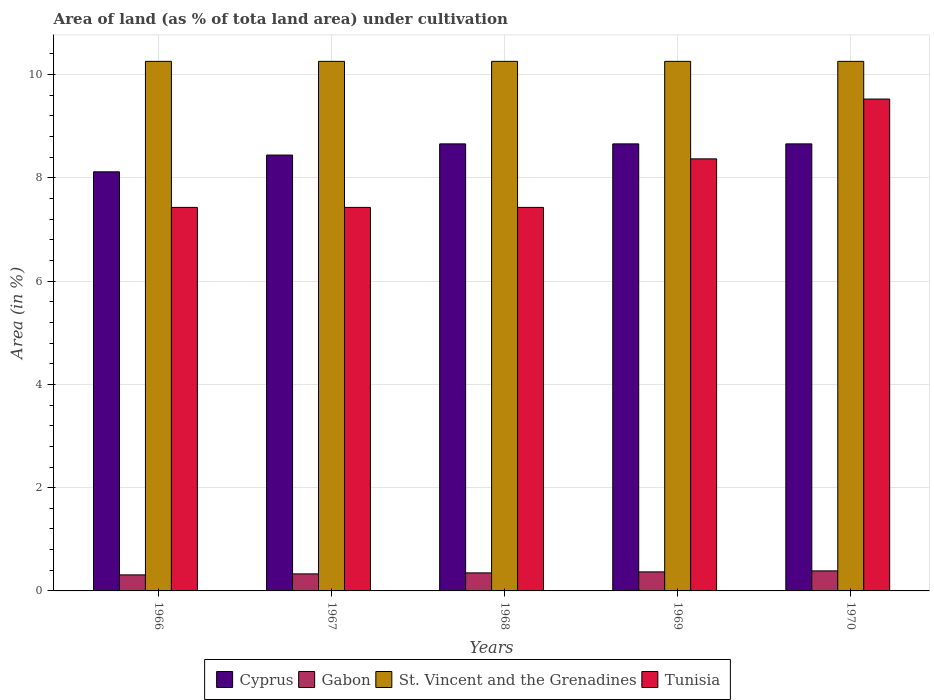How many different coloured bars are there?
Your answer should be very brief. 4. How many groups of bars are there?
Provide a short and direct response. 5. Are the number of bars per tick equal to the number of legend labels?
Provide a short and direct response. Yes. What is the label of the 2nd group of bars from the left?
Keep it short and to the point. 1967. In how many cases, is the number of bars for a given year not equal to the number of legend labels?
Keep it short and to the point. 0. What is the percentage of land under cultivation in St. Vincent and the Grenadines in 1968?
Ensure brevity in your answer.  10.26. Across all years, what is the maximum percentage of land under cultivation in Cyprus?
Your response must be concise. 8.66. Across all years, what is the minimum percentage of land under cultivation in Cyprus?
Keep it short and to the point. 8.12. In which year was the percentage of land under cultivation in Cyprus minimum?
Ensure brevity in your answer.  1966. What is the total percentage of land under cultivation in Tunisia in the graph?
Ensure brevity in your answer.  40.18. What is the difference between the percentage of land under cultivation in Gabon in 1966 and that in 1967?
Offer a terse response. -0.02. What is the difference between the percentage of land under cultivation in Cyprus in 1969 and the percentage of land under cultivation in St. Vincent and the Grenadines in 1966?
Provide a short and direct response. -1.6. What is the average percentage of land under cultivation in Gabon per year?
Make the answer very short. 0.35. In the year 1970, what is the difference between the percentage of land under cultivation in Cyprus and percentage of land under cultivation in St. Vincent and the Grenadines?
Give a very brief answer. -1.6. Is the percentage of land under cultivation in St. Vincent and the Grenadines in 1966 less than that in 1970?
Your answer should be very brief. No. Is the difference between the percentage of land under cultivation in Cyprus in 1966 and 1969 greater than the difference between the percentage of land under cultivation in St. Vincent and the Grenadines in 1966 and 1969?
Offer a terse response. No. What is the difference between the highest and the lowest percentage of land under cultivation in St. Vincent and the Grenadines?
Give a very brief answer. 0. Is the sum of the percentage of land under cultivation in Gabon in 1966 and 1967 greater than the maximum percentage of land under cultivation in Cyprus across all years?
Ensure brevity in your answer.  No. What does the 3rd bar from the left in 1966 represents?
Provide a short and direct response. St. Vincent and the Grenadines. What does the 2nd bar from the right in 1969 represents?
Provide a succinct answer. St. Vincent and the Grenadines. How many bars are there?
Provide a short and direct response. 20. How many years are there in the graph?
Provide a succinct answer. 5. What is the difference between two consecutive major ticks on the Y-axis?
Give a very brief answer. 2. Are the values on the major ticks of Y-axis written in scientific E-notation?
Give a very brief answer. No. Where does the legend appear in the graph?
Make the answer very short. Bottom center. What is the title of the graph?
Offer a very short reply. Area of land (as % of tota land area) under cultivation. Does "Korea (Republic)" appear as one of the legend labels in the graph?
Keep it short and to the point. No. What is the label or title of the X-axis?
Offer a very short reply. Years. What is the label or title of the Y-axis?
Provide a short and direct response. Area (in %). What is the Area (in %) of Cyprus in 1966?
Your response must be concise. 8.12. What is the Area (in %) in Gabon in 1966?
Your response must be concise. 0.31. What is the Area (in %) in St. Vincent and the Grenadines in 1966?
Your response must be concise. 10.26. What is the Area (in %) in Tunisia in 1966?
Provide a succinct answer. 7.43. What is the Area (in %) of Cyprus in 1967?
Offer a very short reply. 8.44. What is the Area (in %) in Gabon in 1967?
Offer a very short reply. 0.33. What is the Area (in %) in St. Vincent and the Grenadines in 1967?
Your answer should be compact. 10.26. What is the Area (in %) in Tunisia in 1967?
Offer a terse response. 7.43. What is the Area (in %) in Cyprus in 1968?
Your answer should be compact. 8.66. What is the Area (in %) in Gabon in 1968?
Provide a short and direct response. 0.35. What is the Area (in %) of St. Vincent and the Grenadines in 1968?
Provide a short and direct response. 10.26. What is the Area (in %) in Tunisia in 1968?
Your answer should be compact. 7.43. What is the Area (in %) of Cyprus in 1969?
Ensure brevity in your answer.  8.66. What is the Area (in %) of Gabon in 1969?
Offer a terse response. 0.37. What is the Area (in %) in St. Vincent and the Grenadines in 1969?
Ensure brevity in your answer.  10.26. What is the Area (in %) of Tunisia in 1969?
Ensure brevity in your answer.  8.37. What is the Area (in %) in Cyprus in 1970?
Ensure brevity in your answer.  8.66. What is the Area (in %) of Gabon in 1970?
Provide a succinct answer. 0.39. What is the Area (in %) of St. Vincent and the Grenadines in 1970?
Ensure brevity in your answer.  10.26. What is the Area (in %) of Tunisia in 1970?
Offer a very short reply. 9.53. Across all years, what is the maximum Area (in %) in Cyprus?
Your answer should be very brief. 8.66. Across all years, what is the maximum Area (in %) of Gabon?
Your answer should be very brief. 0.39. Across all years, what is the maximum Area (in %) of St. Vincent and the Grenadines?
Your answer should be very brief. 10.26. Across all years, what is the maximum Area (in %) of Tunisia?
Keep it short and to the point. 9.53. Across all years, what is the minimum Area (in %) of Cyprus?
Your answer should be compact. 8.12. Across all years, what is the minimum Area (in %) of Gabon?
Provide a succinct answer. 0.31. Across all years, what is the minimum Area (in %) in St. Vincent and the Grenadines?
Offer a very short reply. 10.26. Across all years, what is the minimum Area (in %) in Tunisia?
Keep it short and to the point. 7.43. What is the total Area (in %) of Cyprus in the graph?
Make the answer very short. 42.53. What is the total Area (in %) of Gabon in the graph?
Offer a terse response. 1.75. What is the total Area (in %) in St. Vincent and the Grenadines in the graph?
Offer a very short reply. 51.28. What is the total Area (in %) in Tunisia in the graph?
Your response must be concise. 40.18. What is the difference between the Area (in %) in Cyprus in 1966 and that in 1967?
Your answer should be compact. -0.32. What is the difference between the Area (in %) of Gabon in 1966 and that in 1967?
Offer a terse response. -0.02. What is the difference between the Area (in %) of St. Vincent and the Grenadines in 1966 and that in 1967?
Your answer should be compact. 0. What is the difference between the Area (in %) in Cyprus in 1966 and that in 1968?
Keep it short and to the point. -0.54. What is the difference between the Area (in %) of Gabon in 1966 and that in 1968?
Your response must be concise. -0.04. What is the difference between the Area (in %) in St. Vincent and the Grenadines in 1966 and that in 1968?
Provide a short and direct response. 0. What is the difference between the Area (in %) in Cyprus in 1966 and that in 1969?
Offer a terse response. -0.54. What is the difference between the Area (in %) of Gabon in 1966 and that in 1969?
Make the answer very short. -0.06. What is the difference between the Area (in %) of St. Vincent and the Grenadines in 1966 and that in 1969?
Ensure brevity in your answer.  0. What is the difference between the Area (in %) of Tunisia in 1966 and that in 1969?
Make the answer very short. -0.94. What is the difference between the Area (in %) in Cyprus in 1966 and that in 1970?
Give a very brief answer. -0.54. What is the difference between the Area (in %) of Gabon in 1966 and that in 1970?
Provide a short and direct response. -0.08. What is the difference between the Area (in %) in Tunisia in 1966 and that in 1970?
Ensure brevity in your answer.  -2.1. What is the difference between the Area (in %) in Cyprus in 1967 and that in 1968?
Make the answer very short. -0.22. What is the difference between the Area (in %) of Gabon in 1967 and that in 1968?
Make the answer very short. -0.02. What is the difference between the Area (in %) of Tunisia in 1967 and that in 1968?
Offer a very short reply. 0. What is the difference between the Area (in %) of Cyprus in 1967 and that in 1969?
Provide a succinct answer. -0.22. What is the difference between the Area (in %) of Gabon in 1967 and that in 1969?
Ensure brevity in your answer.  -0.04. What is the difference between the Area (in %) in St. Vincent and the Grenadines in 1967 and that in 1969?
Ensure brevity in your answer.  0. What is the difference between the Area (in %) of Tunisia in 1967 and that in 1969?
Offer a very short reply. -0.94. What is the difference between the Area (in %) of Cyprus in 1967 and that in 1970?
Your answer should be compact. -0.22. What is the difference between the Area (in %) of Gabon in 1967 and that in 1970?
Your answer should be very brief. -0.06. What is the difference between the Area (in %) in St. Vincent and the Grenadines in 1967 and that in 1970?
Ensure brevity in your answer.  0. What is the difference between the Area (in %) in Tunisia in 1967 and that in 1970?
Provide a short and direct response. -2.1. What is the difference between the Area (in %) of Gabon in 1968 and that in 1969?
Keep it short and to the point. -0.02. What is the difference between the Area (in %) of Tunisia in 1968 and that in 1969?
Give a very brief answer. -0.94. What is the difference between the Area (in %) in Gabon in 1968 and that in 1970?
Offer a terse response. -0.04. What is the difference between the Area (in %) in St. Vincent and the Grenadines in 1968 and that in 1970?
Provide a short and direct response. 0. What is the difference between the Area (in %) in Tunisia in 1968 and that in 1970?
Your answer should be compact. -2.1. What is the difference between the Area (in %) of Cyprus in 1969 and that in 1970?
Give a very brief answer. 0. What is the difference between the Area (in %) of Gabon in 1969 and that in 1970?
Make the answer very short. -0.02. What is the difference between the Area (in %) in Tunisia in 1969 and that in 1970?
Your answer should be very brief. -1.16. What is the difference between the Area (in %) in Cyprus in 1966 and the Area (in %) in Gabon in 1967?
Provide a succinct answer. 7.79. What is the difference between the Area (in %) in Cyprus in 1966 and the Area (in %) in St. Vincent and the Grenadines in 1967?
Ensure brevity in your answer.  -2.14. What is the difference between the Area (in %) of Cyprus in 1966 and the Area (in %) of Tunisia in 1967?
Your answer should be very brief. 0.69. What is the difference between the Area (in %) of Gabon in 1966 and the Area (in %) of St. Vincent and the Grenadines in 1967?
Ensure brevity in your answer.  -9.95. What is the difference between the Area (in %) in Gabon in 1966 and the Area (in %) in Tunisia in 1967?
Provide a succinct answer. -7.12. What is the difference between the Area (in %) in St. Vincent and the Grenadines in 1966 and the Area (in %) in Tunisia in 1967?
Your response must be concise. 2.83. What is the difference between the Area (in %) of Cyprus in 1966 and the Area (in %) of Gabon in 1968?
Provide a succinct answer. 7.77. What is the difference between the Area (in %) in Cyprus in 1966 and the Area (in %) in St. Vincent and the Grenadines in 1968?
Provide a succinct answer. -2.14. What is the difference between the Area (in %) in Cyprus in 1966 and the Area (in %) in Tunisia in 1968?
Give a very brief answer. 0.69. What is the difference between the Area (in %) in Gabon in 1966 and the Area (in %) in St. Vincent and the Grenadines in 1968?
Your answer should be compact. -9.95. What is the difference between the Area (in %) of Gabon in 1966 and the Area (in %) of Tunisia in 1968?
Ensure brevity in your answer.  -7.12. What is the difference between the Area (in %) in St. Vincent and the Grenadines in 1966 and the Area (in %) in Tunisia in 1968?
Make the answer very short. 2.83. What is the difference between the Area (in %) of Cyprus in 1966 and the Area (in %) of Gabon in 1969?
Provide a succinct answer. 7.75. What is the difference between the Area (in %) of Cyprus in 1966 and the Area (in %) of St. Vincent and the Grenadines in 1969?
Make the answer very short. -2.14. What is the difference between the Area (in %) in Cyprus in 1966 and the Area (in %) in Tunisia in 1969?
Ensure brevity in your answer.  -0.25. What is the difference between the Area (in %) of Gabon in 1966 and the Area (in %) of St. Vincent and the Grenadines in 1969?
Provide a succinct answer. -9.95. What is the difference between the Area (in %) of Gabon in 1966 and the Area (in %) of Tunisia in 1969?
Keep it short and to the point. -8.06. What is the difference between the Area (in %) in St. Vincent and the Grenadines in 1966 and the Area (in %) in Tunisia in 1969?
Offer a very short reply. 1.89. What is the difference between the Area (in %) of Cyprus in 1966 and the Area (in %) of Gabon in 1970?
Your answer should be compact. 7.73. What is the difference between the Area (in %) in Cyprus in 1966 and the Area (in %) in St. Vincent and the Grenadines in 1970?
Give a very brief answer. -2.14. What is the difference between the Area (in %) in Cyprus in 1966 and the Area (in %) in Tunisia in 1970?
Make the answer very short. -1.41. What is the difference between the Area (in %) of Gabon in 1966 and the Area (in %) of St. Vincent and the Grenadines in 1970?
Keep it short and to the point. -9.95. What is the difference between the Area (in %) in Gabon in 1966 and the Area (in %) in Tunisia in 1970?
Provide a succinct answer. -9.22. What is the difference between the Area (in %) in St. Vincent and the Grenadines in 1966 and the Area (in %) in Tunisia in 1970?
Make the answer very short. 0.73. What is the difference between the Area (in %) in Cyprus in 1967 and the Area (in %) in Gabon in 1968?
Your response must be concise. 8.09. What is the difference between the Area (in %) of Cyprus in 1967 and the Area (in %) of St. Vincent and the Grenadines in 1968?
Provide a succinct answer. -1.81. What is the difference between the Area (in %) in Cyprus in 1967 and the Area (in %) in Tunisia in 1968?
Your answer should be very brief. 1.01. What is the difference between the Area (in %) of Gabon in 1967 and the Area (in %) of St. Vincent and the Grenadines in 1968?
Make the answer very short. -9.93. What is the difference between the Area (in %) of Gabon in 1967 and the Area (in %) of Tunisia in 1968?
Offer a terse response. -7.1. What is the difference between the Area (in %) of St. Vincent and the Grenadines in 1967 and the Area (in %) of Tunisia in 1968?
Your answer should be very brief. 2.83. What is the difference between the Area (in %) of Cyprus in 1967 and the Area (in %) of Gabon in 1969?
Provide a succinct answer. 8.07. What is the difference between the Area (in %) of Cyprus in 1967 and the Area (in %) of St. Vincent and the Grenadines in 1969?
Your answer should be compact. -1.81. What is the difference between the Area (in %) in Cyprus in 1967 and the Area (in %) in Tunisia in 1969?
Provide a succinct answer. 0.07. What is the difference between the Area (in %) of Gabon in 1967 and the Area (in %) of St. Vincent and the Grenadines in 1969?
Provide a succinct answer. -9.93. What is the difference between the Area (in %) of Gabon in 1967 and the Area (in %) of Tunisia in 1969?
Your answer should be compact. -8.04. What is the difference between the Area (in %) of St. Vincent and the Grenadines in 1967 and the Area (in %) of Tunisia in 1969?
Your response must be concise. 1.89. What is the difference between the Area (in %) of Cyprus in 1967 and the Area (in %) of Gabon in 1970?
Make the answer very short. 8.05. What is the difference between the Area (in %) of Cyprus in 1967 and the Area (in %) of St. Vincent and the Grenadines in 1970?
Your answer should be compact. -1.81. What is the difference between the Area (in %) of Cyprus in 1967 and the Area (in %) of Tunisia in 1970?
Provide a short and direct response. -1.08. What is the difference between the Area (in %) in Gabon in 1967 and the Area (in %) in St. Vincent and the Grenadines in 1970?
Give a very brief answer. -9.93. What is the difference between the Area (in %) of Gabon in 1967 and the Area (in %) of Tunisia in 1970?
Your answer should be very brief. -9.2. What is the difference between the Area (in %) of St. Vincent and the Grenadines in 1967 and the Area (in %) of Tunisia in 1970?
Keep it short and to the point. 0.73. What is the difference between the Area (in %) of Cyprus in 1968 and the Area (in %) of Gabon in 1969?
Your answer should be compact. 8.29. What is the difference between the Area (in %) of Cyprus in 1968 and the Area (in %) of St. Vincent and the Grenadines in 1969?
Your response must be concise. -1.6. What is the difference between the Area (in %) of Cyprus in 1968 and the Area (in %) of Tunisia in 1969?
Your answer should be compact. 0.29. What is the difference between the Area (in %) in Gabon in 1968 and the Area (in %) in St. Vincent and the Grenadines in 1969?
Offer a very short reply. -9.91. What is the difference between the Area (in %) of Gabon in 1968 and the Area (in %) of Tunisia in 1969?
Your answer should be compact. -8.02. What is the difference between the Area (in %) in St. Vincent and the Grenadines in 1968 and the Area (in %) in Tunisia in 1969?
Provide a succinct answer. 1.89. What is the difference between the Area (in %) of Cyprus in 1968 and the Area (in %) of Gabon in 1970?
Make the answer very short. 8.27. What is the difference between the Area (in %) of Cyprus in 1968 and the Area (in %) of St. Vincent and the Grenadines in 1970?
Your answer should be compact. -1.6. What is the difference between the Area (in %) in Cyprus in 1968 and the Area (in %) in Tunisia in 1970?
Make the answer very short. -0.87. What is the difference between the Area (in %) in Gabon in 1968 and the Area (in %) in St. Vincent and the Grenadines in 1970?
Your answer should be very brief. -9.91. What is the difference between the Area (in %) in Gabon in 1968 and the Area (in %) in Tunisia in 1970?
Ensure brevity in your answer.  -9.18. What is the difference between the Area (in %) in St. Vincent and the Grenadines in 1968 and the Area (in %) in Tunisia in 1970?
Your answer should be very brief. 0.73. What is the difference between the Area (in %) of Cyprus in 1969 and the Area (in %) of Gabon in 1970?
Provide a succinct answer. 8.27. What is the difference between the Area (in %) in Cyprus in 1969 and the Area (in %) in St. Vincent and the Grenadines in 1970?
Your answer should be compact. -1.6. What is the difference between the Area (in %) in Cyprus in 1969 and the Area (in %) in Tunisia in 1970?
Make the answer very short. -0.87. What is the difference between the Area (in %) in Gabon in 1969 and the Area (in %) in St. Vincent and the Grenadines in 1970?
Give a very brief answer. -9.89. What is the difference between the Area (in %) in Gabon in 1969 and the Area (in %) in Tunisia in 1970?
Offer a terse response. -9.16. What is the difference between the Area (in %) in St. Vincent and the Grenadines in 1969 and the Area (in %) in Tunisia in 1970?
Your answer should be compact. 0.73. What is the average Area (in %) in Cyprus per year?
Your answer should be very brief. 8.51. What is the average Area (in %) of Gabon per year?
Offer a very short reply. 0.35. What is the average Area (in %) of St. Vincent and the Grenadines per year?
Your response must be concise. 10.26. What is the average Area (in %) in Tunisia per year?
Provide a succinct answer. 8.04. In the year 1966, what is the difference between the Area (in %) of Cyprus and Area (in %) of Gabon?
Provide a succinct answer. 7.81. In the year 1966, what is the difference between the Area (in %) of Cyprus and Area (in %) of St. Vincent and the Grenadines?
Offer a terse response. -2.14. In the year 1966, what is the difference between the Area (in %) in Cyprus and Area (in %) in Tunisia?
Your response must be concise. 0.69. In the year 1966, what is the difference between the Area (in %) of Gabon and Area (in %) of St. Vincent and the Grenadines?
Your answer should be very brief. -9.95. In the year 1966, what is the difference between the Area (in %) in Gabon and Area (in %) in Tunisia?
Keep it short and to the point. -7.12. In the year 1966, what is the difference between the Area (in %) of St. Vincent and the Grenadines and Area (in %) of Tunisia?
Offer a very short reply. 2.83. In the year 1967, what is the difference between the Area (in %) in Cyprus and Area (in %) in Gabon?
Your answer should be very brief. 8.11. In the year 1967, what is the difference between the Area (in %) of Cyprus and Area (in %) of St. Vincent and the Grenadines?
Your answer should be compact. -1.81. In the year 1967, what is the difference between the Area (in %) in Cyprus and Area (in %) in Tunisia?
Make the answer very short. 1.01. In the year 1967, what is the difference between the Area (in %) of Gabon and Area (in %) of St. Vincent and the Grenadines?
Your answer should be very brief. -9.93. In the year 1967, what is the difference between the Area (in %) of Gabon and Area (in %) of Tunisia?
Offer a very short reply. -7.1. In the year 1967, what is the difference between the Area (in %) in St. Vincent and the Grenadines and Area (in %) in Tunisia?
Provide a succinct answer. 2.83. In the year 1968, what is the difference between the Area (in %) in Cyprus and Area (in %) in Gabon?
Offer a very short reply. 8.31. In the year 1968, what is the difference between the Area (in %) in Cyprus and Area (in %) in St. Vincent and the Grenadines?
Your answer should be compact. -1.6. In the year 1968, what is the difference between the Area (in %) of Cyprus and Area (in %) of Tunisia?
Your response must be concise. 1.23. In the year 1968, what is the difference between the Area (in %) in Gabon and Area (in %) in St. Vincent and the Grenadines?
Ensure brevity in your answer.  -9.91. In the year 1968, what is the difference between the Area (in %) of Gabon and Area (in %) of Tunisia?
Your answer should be compact. -7.08. In the year 1968, what is the difference between the Area (in %) in St. Vincent and the Grenadines and Area (in %) in Tunisia?
Offer a very short reply. 2.83. In the year 1969, what is the difference between the Area (in %) in Cyprus and Area (in %) in Gabon?
Offer a terse response. 8.29. In the year 1969, what is the difference between the Area (in %) of Cyprus and Area (in %) of St. Vincent and the Grenadines?
Provide a short and direct response. -1.6. In the year 1969, what is the difference between the Area (in %) in Cyprus and Area (in %) in Tunisia?
Ensure brevity in your answer.  0.29. In the year 1969, what is the difference between the Area (in %) in Gabon and Area (in %) in St. Vincent and the Grenadines?
Your answer should be compact. -9.89. In the year 1969, what is the difference between the Area (in %) of Gabon and Area (in %) of Tunisia?
Offer a terse response. -8. In the year 1969, what is the difference between the Area (in %) of St. Vincent and the Grenadines and Area (in %) of Tunisia?
Make the answer very short. 1.89. In the year 1970, what is the difference between the Area (in %) in Cyprus and Area (in %) in Gabon?
Provide a succinct answer. 8.27. In the year 1970, what is the difference between the Area (in %) of Cyprus and Area (in %) of St. Vincent and the Grenadines?
Make the answer very short. -1.6. In the year 1970, what is the difference between the Area (in %) of Cyprus and Area (in %) of Tunisia?
Your answer should be compact. -0.87. In the year 1970, what is the difference between the Area (in %) of Gabon and Area (in %) of St. Vincent and the Grenadines?
Keep it short and to the point. -9.87. In the year 1970, what is the difference between the Area (in %) of Gabon and Area (in %) of Tunisia?
Offer a terse response. -9.14. In the year 1970, what is the difference between the Area (in %) of St. Vincent and the Grenadines and Area (in %) of Tunisia?
Make the answer very short. 0.73. What is the ratio of the Area (in %) in Cyprus in 1966 to that in 1967?
Give a very brief answer. 0.96. What is the ratio of the Area (in %) in St. Vincent and the Grenadines in 1966 to that in 1967?
Ensure brevity in your answer.  1. What is the ratio of the Area (in %) of Tunisia in 1966 to that in 1967?
Ensure brevity in your answer.  1. What is the ratio of the Area (in %) in Cyprus in 1966 to that in 1968?
Give a very brief answer. 0.94. What is the ratio of the Area (in %) of Gabon in 1966 to that in 1969?
Give a very brief answer. 0.84. What is the ratio of the Area (in %) of St. Vincent and the Grenadines in 1966 to that in 1969?
Give a very brief answer. 1. What is the ratio of the Area (in %) of Tunisia in 1966 to that in 1969?
Offer a very short reply. 0.89. What is the ratio of the Area (in %) of Gabon in 1966 to that in 1970?
Offer a very short reply. 0.8. What is the ratio of the Area (in %) of St. Vincent and the Grenadines in 1966 to that in 1970?
Provide a short and direct response. 1. What is the ratio of the Area (in %) in Tunisia in 1966 to that in 1970?
Your answer should be compact. 0.78. What is the ratio of the Area (in %) in Cyprus in 1967 to that in 1968?
Ensure brevity in your answer.  0.97. What is the ratio of the Area (in %) of Gabon in 1967 to that in 1968?
Give a very brief answer. 0.94. What is the ratio of the Area (in %) in Tunisia in 1967 to that in 1968?
Your response must be concise. 1. What is the ratio of the Area (in %) of Cyprus in 1967 to that in 1969?
Keep it short and to the point. 0.97. What is the ratio of the Area (in %) of Gabon in 1967 to that in 1969?
Ensure brevity in your answer.  0.89. What is the ratio of the Area (in %) of St. Vincent and the Grenadines in 1967 to that in 1969?
Your response must be concise. 1. What is the ratio of the Area (in %) in Tunisia in 1967 to that in 1969?
Give a very brief answer. 0.89. What is the ratio of the Area (in %) of Tunisia in 1967 to that in 1970?
Keep it short and to the point. 0.78. What is the ratio of the Area (in %) in St. Vincent and the Grenadines in 1968 to that in 1969?
Give a very brief answer. 1. What is the ratio of the Area (in %) in Tunisia in 1968 to that in 1969?
Offer a very short reply. 0.89. What is the ratio of the Area (in %) in Cyprus in 1968 to that in 1970?
Provide a succinct answer. 1. What is the ratio of the Area (in %) in Gabon in 1968 to that in 1970?
Provide a short and direct response. 0.9. What is the ratio of the Area (in %) of Tunisia in 1968 to that in 1970?
Give a very brief answer. 0.78. What is the ratio of the Area (in %) in St. Vincent and the Grenadines in 1969 to that in 1970?
Make the answer very short. 1. What is the ratio of the Area (in %) of Tunisia in 1969 to that in 1970?
Offer a terse response. 0.88. What is the difference between the highest and the second highest Area (in %) of Cyprus?
Your answer should be compact. 0. What is the difference between the highest and the second highest Area (in %) in Gabon?
Give a very brief answer. 0.02. What is the difference between the highest and the second highest Area (in %) in St. Vincent and the Grenadines?
Give a very brief answer. 0. What is the difference between the highest and the second highest Area (in %) in Tunisia?
Offer a terse response. 1.16. What is the difference between the highest and the lowest Area (in %) in Cyprus?
Provide a short and direct response. 0.54. What is the difference between the highest and the lowest Area (in %) in Gabon?
Provide a short and direct response. 0.08. What is the difference between the highest and the lowest Area (in %) in Tunisia?
Offer a very short reply. 2.1. 